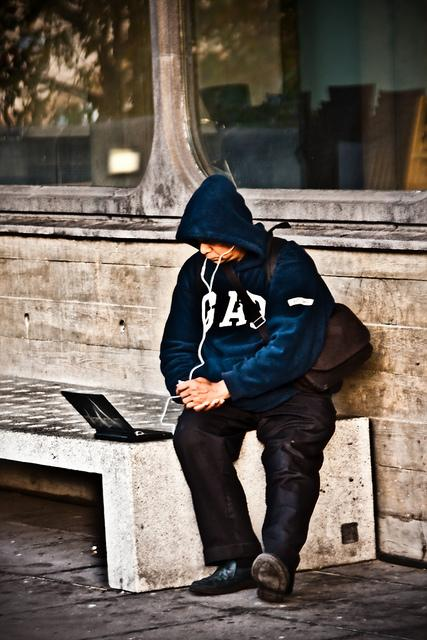What is the man sitting there doing?

Choices:
A) preparing powerpoint
B) watching video
C) preparing document
D) sending email watching video 